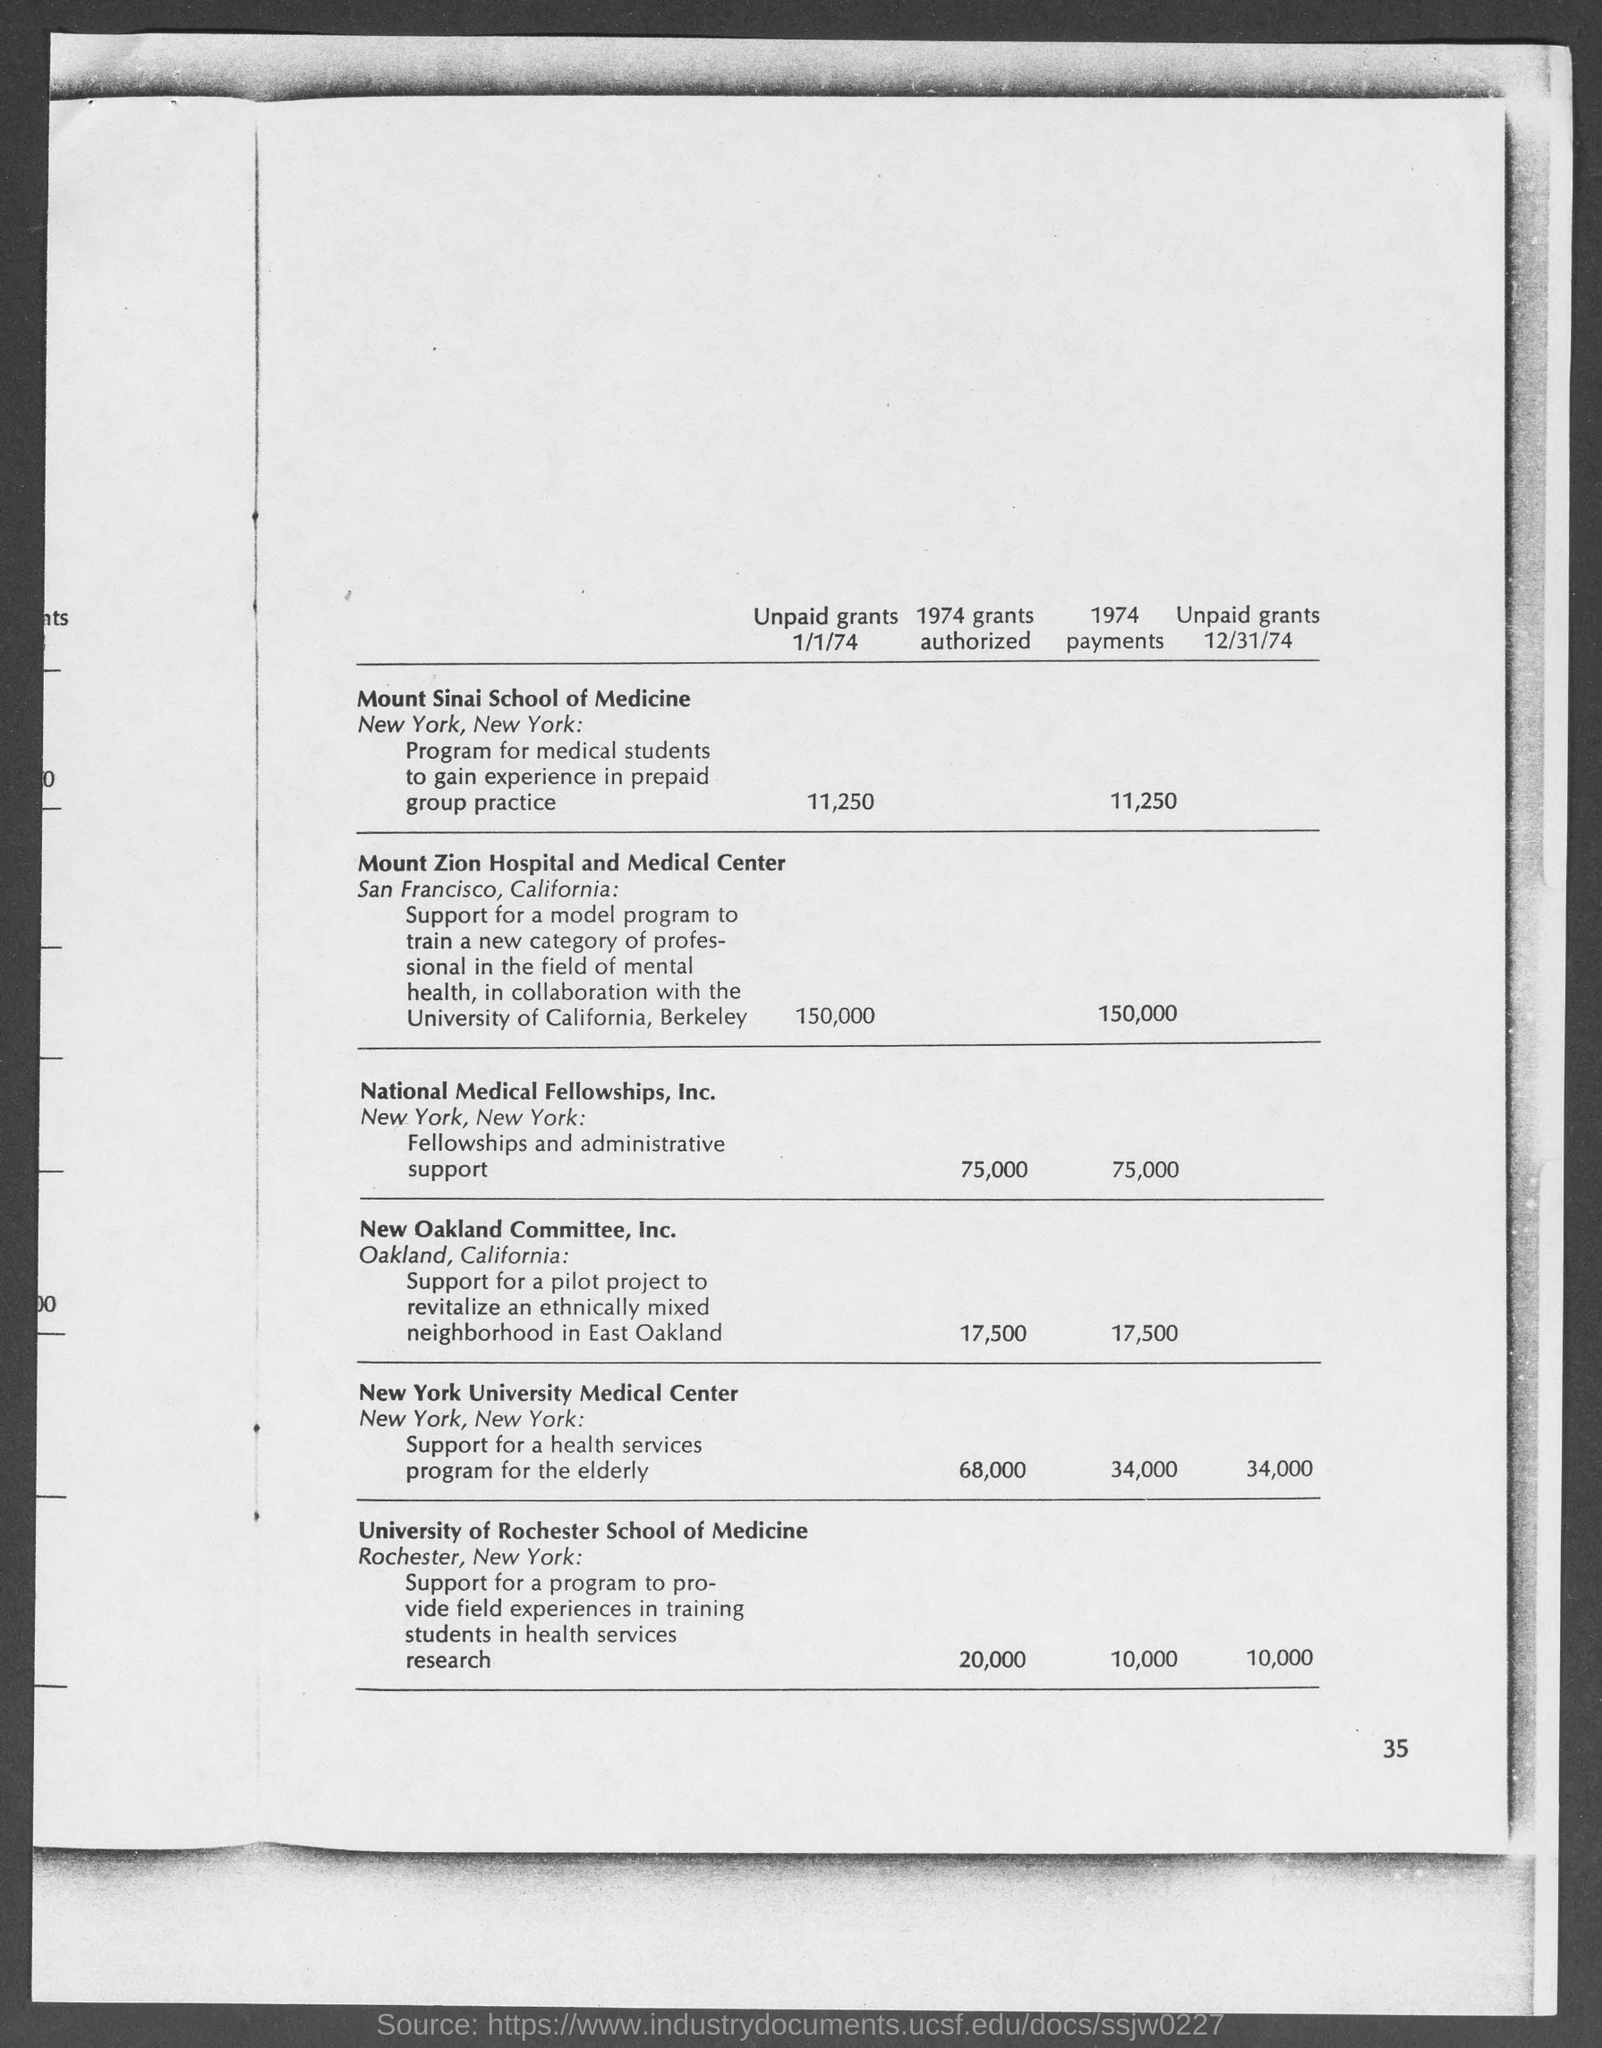Point out several critical features in this image. In 1974, the payments for Mount Sinai School of Medicine were $11,250. In the year 1974, the University of Rochester School of Medicine was authorized to receive a grant of 20,000 for a specific purpose. In 1974, the New Oakland Committee, Inc. was authorized to receive a grant amounting to $17,500. In 1974, $75,000 was authorized as a grant for National Medical Fellowships, Inc. In 1974, New Oakland Committee, Inc. received a total of 17,500 payments. 